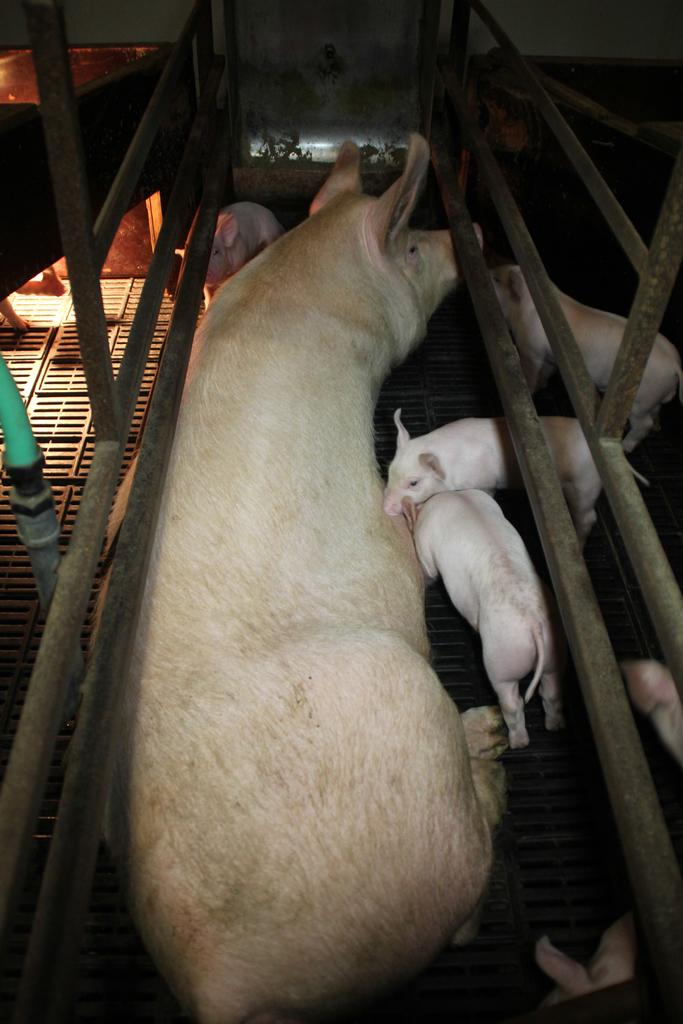What type of animals are present in the image? There are small pigs and a big pig in the image. What structures can be seen in the image? Pipes, fencing, a door, and a wall are visible in the image. Can you describe the location of the door and wall in the image? The door and wall are at the top of the image. What type of popcorn can be seen on the moon in the image? There is no moon or popcorn present in the image. What type of line can be seen connecting the pigs in the image? There is no line connecting the pigs in the image. 